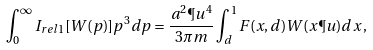Convert formula to latex. <formula><loc_0><loc_0><loc_500><loc_500>\int _ { 0 } ^ { \infty } I _ { r e l 1 } [ W ( p ) ] p ^ { 3 } d p = \frac { a ^ { 2 } \P u ^ { 4 } } { 3 \pi m } \int _ { d } ^ { 1 } F ( x , d ) W ( x \P u ) d x \, ,</formula> 